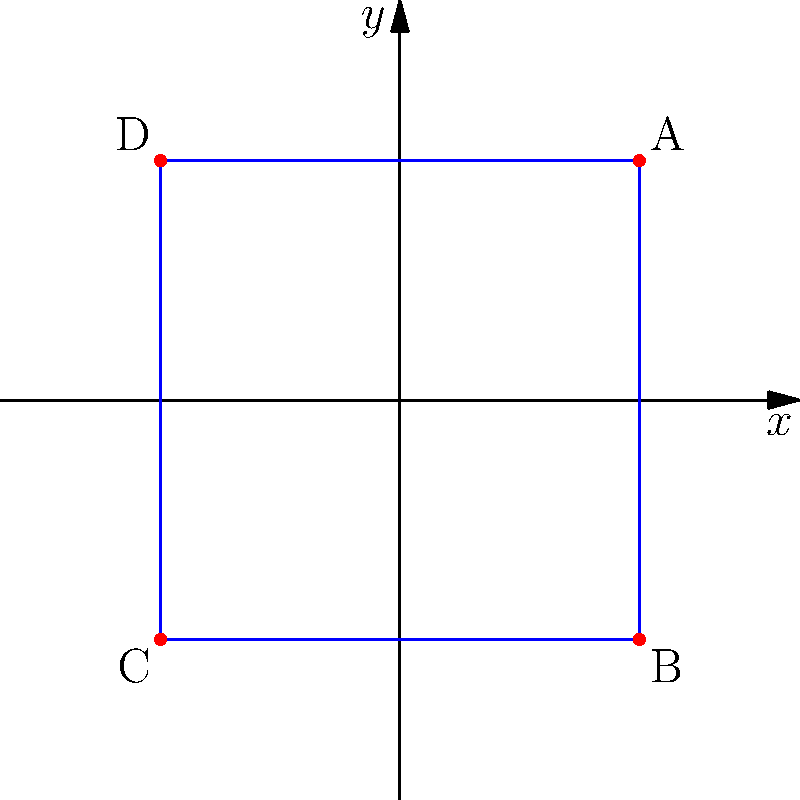You need to set up a secure perimeter around a building for conducting sensitive interviews. The building is represented by a square on a coordinate plane, with corners at (3,3), (3,-3), (-3,-3), and (-3,3). What is the area of the secure zone defined by this perimeter? To find the area of the secure zone, we need to follow these steps:

1. Identify the shape: The secure zone is a square on the coordinate plane.

2. Calculate the length of one side:
   - The square's corners are at (3,3), (3,-3), (-3,-3), and (-3,3).
   - The length of a side can be found by calculating the distance between any two adjacent corners.
   - Let's use the top side, from (-3,3) to (3,3).
   - The distance is: $\sqrt{(3-(-3))^2 + (3-3)^2} = \sqrt{6^2 + 0^2} = 6$

3. Calculate the area:
   - The area of a square is given by the formula $A = s^2$, where $s$ is the length of a side.
   - $A = 6^2 = 36$

Therefore, the area of the secure zone is 36 square units.
Answer: 36 square units 